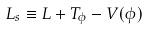<formula> <loc_0><loc_0><loc_500><loc_500>L _ { s } \equiv L + T _ { \phi } - V ( \phi )</formula> 